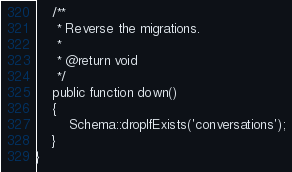<code> <loc_0><loc_0><loc_500><loc_500><_PHP_>    /**
     * Reverse the migrations.
     *
     * @return void
     */
    public function down()
    {
        Schema::dropIfExists('conversations');
    }
}
</code> 